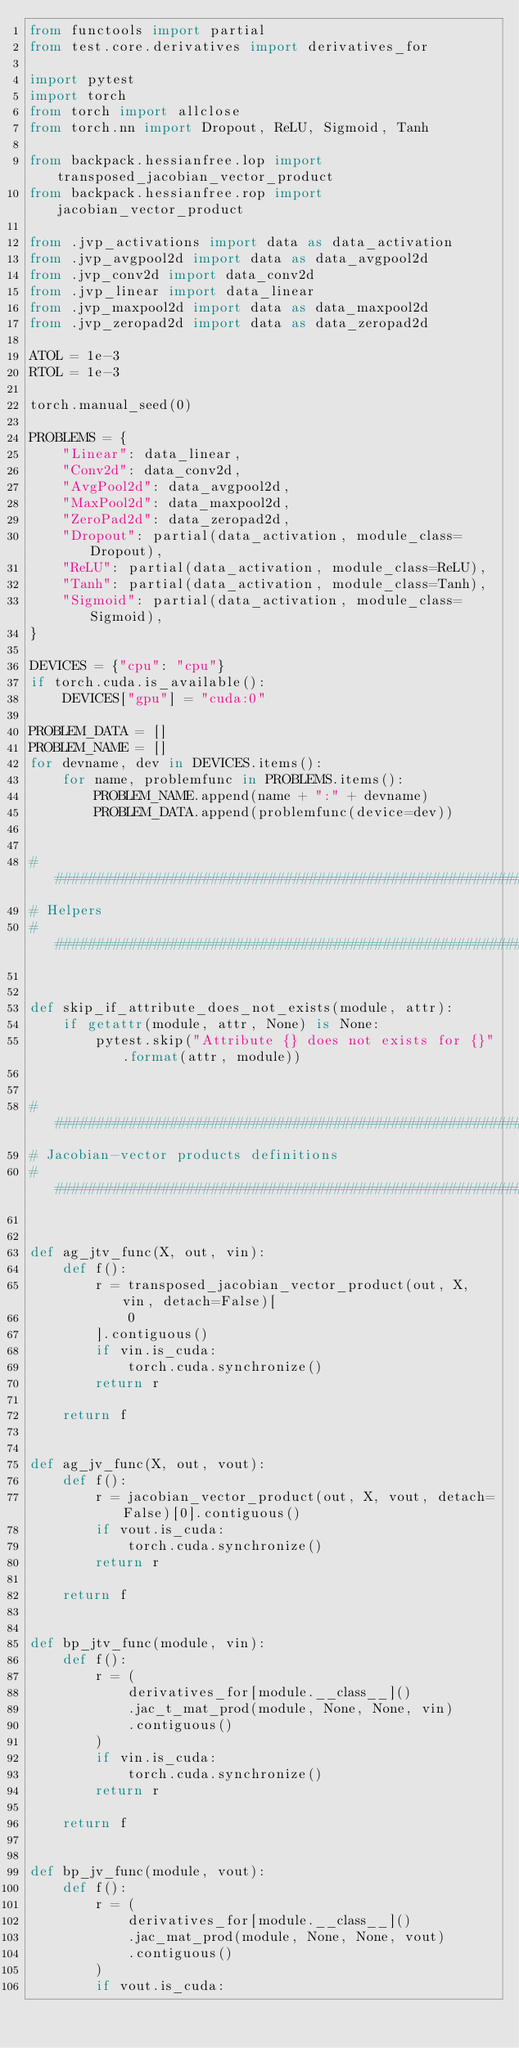<code> <loc_0><loc_0><loc_500><loc_500><_Python_>from functools import partial
from test.core.derivatives import derivatives_for

import pytest
import torch
from torch import allclose
from torch.nn import Dropout, ReLU, Sigmoid, Tanh

from backpack.hessianfree.lop import transposed_jacobian_vector_product
from backpack.hessianfree.rop import jacobian_vector_product

from .jvp_activations import data as data_activation
from .jvp_avgpool2d import data as data_avgpool2d
from .jvp_conv2d import data_conv2d
from .jvp_linear import data_linear
from .jvp_maxpool2d import data as data_maxpool2d
from .jvp_zeropad2d import data as data_zeropad2d

ATOL = 1e-3
RTOL = 1e-3

torch.manual_seed(0)

PROBLEMS = {
    "Linear": data_linear,
    "Conv2d": data_conv2d,
    "AvgPool2d": data_avgpool2d,
    "MaxPool2d": data_maxpool2d,
    "ZeroPad2d": data_zeropad2d,
    "Dropout": partial(data_activation, module_class=Dropout),
    "ReLU": partial(data_activation, module_class=ReLU),
    "Tanh": partial(data_activation, module_class=Tanh),
    "Sigmoid": partial(data_activation, module_class=Sigmoid),
}

DEVICES = {"cpu": "cpu"}
if torch.cuda.is_available():
    DEVICES["gpu"] = "cuda:0"

PROBLEM_DATA = []
PROBLEM_NAME = []
for devname, dev in DEVICES.items():
    for name, problemfunc in PROBLEMS.items():
        PROBLEM_NAME.append(name + ":" + devname)
        PROBLEM_DATA.append(problemfunc(device=dev))


################################################################################
# Helpers
################################################################################


def skip_if_attribute_does_not_exists(module, attr):
    if getattr(module, attr, None) is None:
        pytest.skip("Attribute {} does not exists for {}".format(attr, module))


################################################################################
# Jacobian-vector products definitions
################################################################################


def ag_jtv_func(X, out, vin):
    def f():
        r = transposed_jacobian_vector_product(out, X, vin, detach=False)[
            0
        ].contiguous()
        if vin.is_cuda:
            torch.cuda.synchronize()
        return r

    return f


def ag_jv_func(X, out, vout):
    def f():
        r = jacobian_vector_product(out, X, vout, detach=False)[0].contiguous()
        if vout.is_cuda:
            torch.cuda.synchronize()
        return r

    return f


def bp_jtv_func(module, vin):
    def f():
        r = (
            derivatives_for[module.__class__]()
            .jac_t_mat_prod(module, None, None, vin)
            .contiguous()
        )
        if vin.is_cuda:
            torch.cuda.synchronize()
        return r

    return f


def bp_jv_func(module, vout):
    def f():
        r = (
            derivatives_for[module.__class__]()
            .jac_mat_prod(module, None, None, vout)
            .contiguous()
        )
        if vout.is_cuda:</code> 